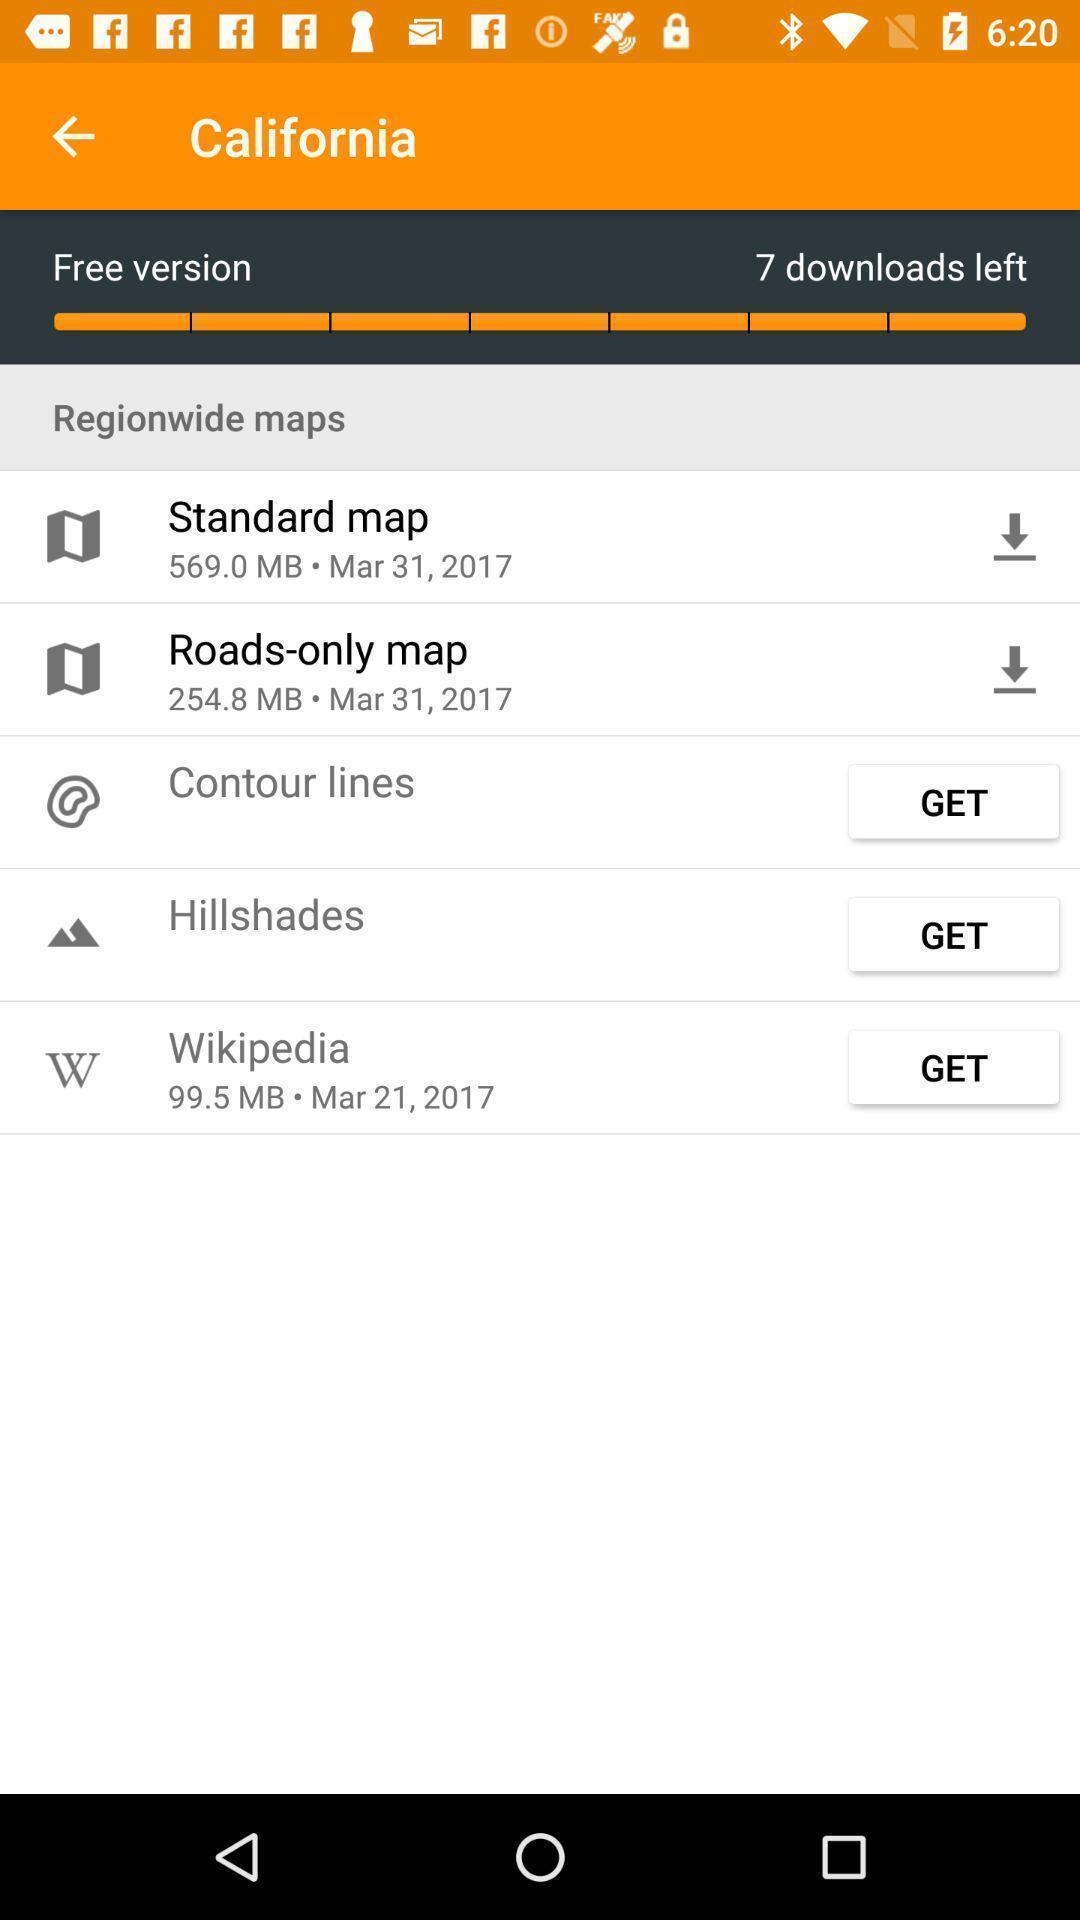What is the overall content of this screenshot? Screen showing region wide maps. 